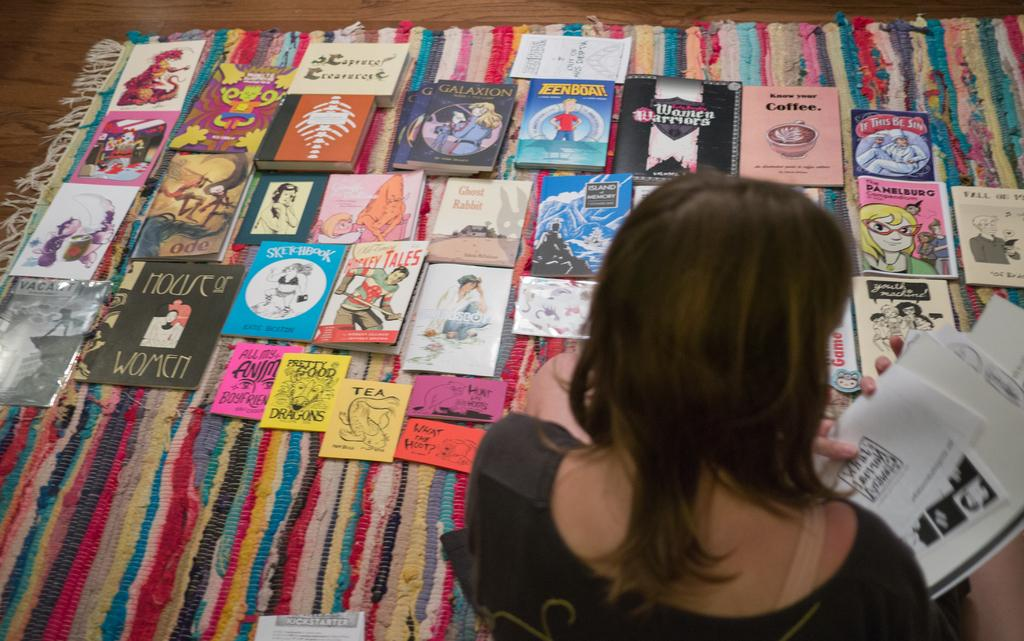Who is present in the image? There is a woman in the image. What is the woman holding in her hands? The woman is holding papers in her hands. What can be seen on the floor in the image? There are books on the carpet in the image. What type of juice is being served at the crime scene in the image? There is no mention of a crime scene or juice in the image; it features a woman holding papers and books on the carpet. 